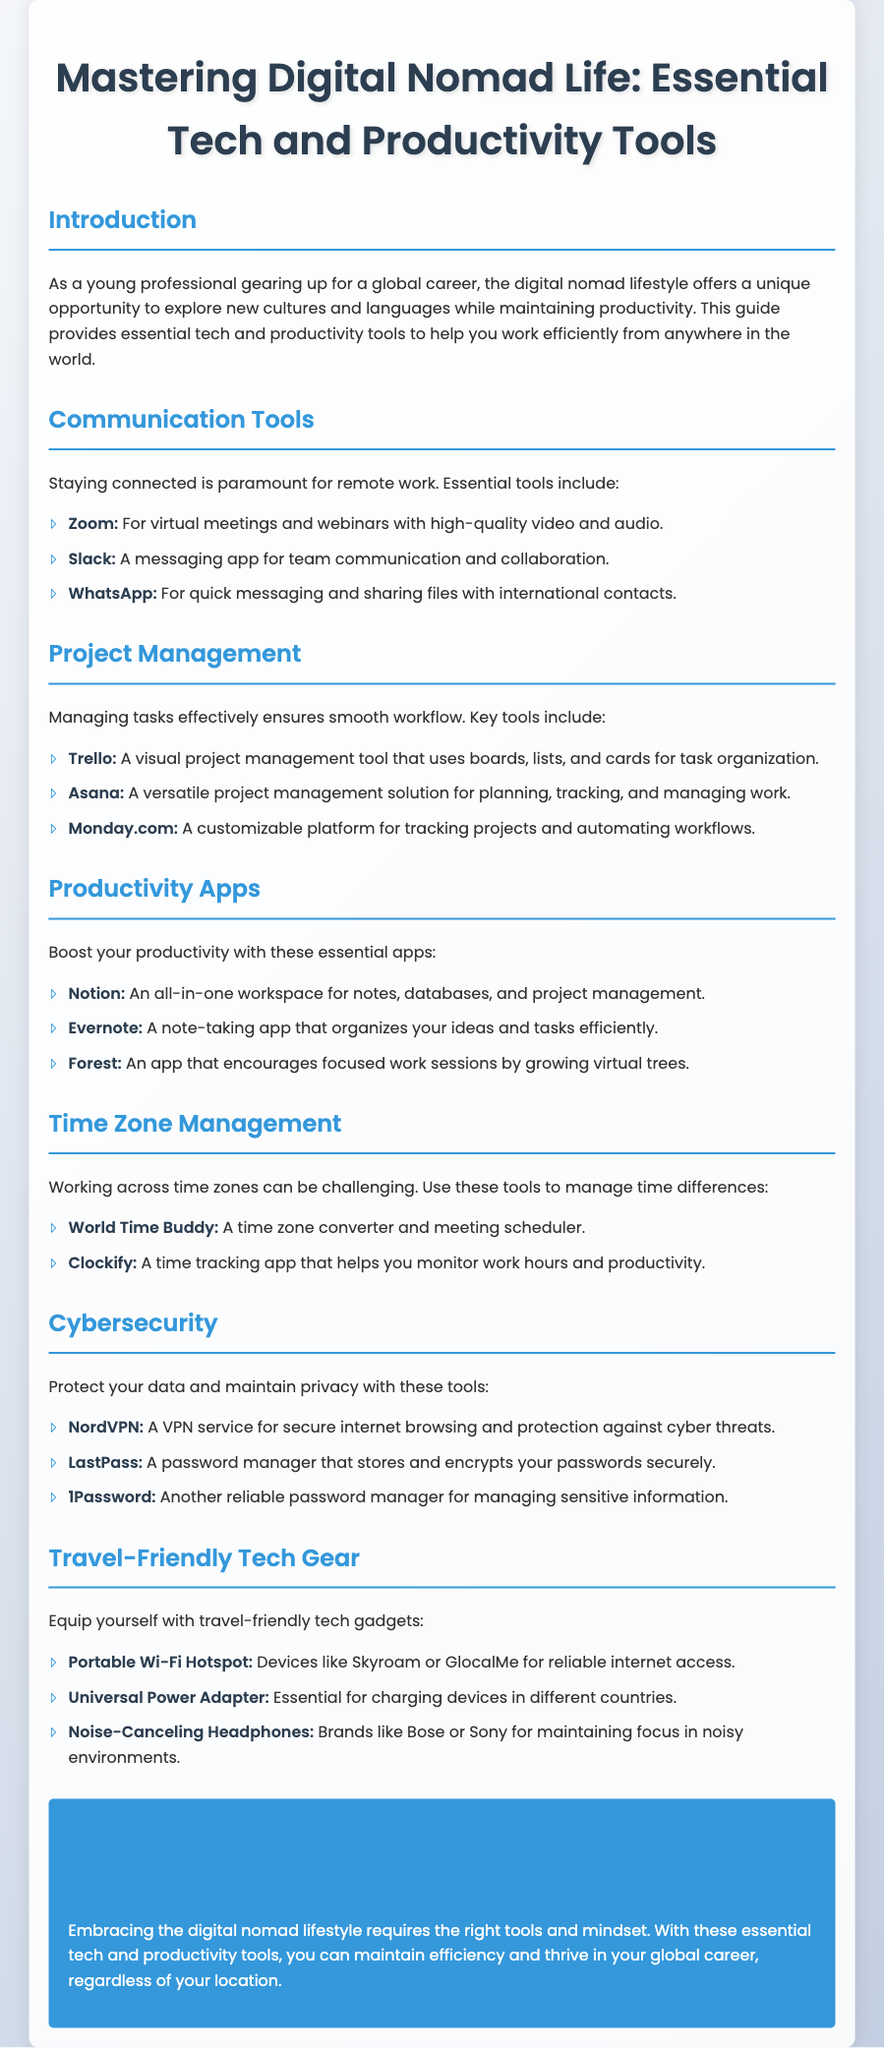what is the title of the guide? The main title of the document is presented in a prominent header at the beginning.
Answer: Mastering Digital Nomad Life: Essential Tech and Productivity Tools what is one example of a communication tool? The document lists several tools under the communication category, and each example reflects a specific tool used for communication.
Answer: Zoom how many project management tools are mentioned? The document explicitly outlines the tools in the project management section which provides a total count.
Answer: 3 which app encourages focused work sessions by growing virtual trees? The document states specific functions of the productivity apps, including features associated with one particular app.
Answer: Forest what tool is used for secure internet browsing? The cybersecurity section of the document includes tools that specifically focus on internet security, naming one of the featured tools.
Answer: NordVPN which portable device is recommended for reliable internet access? The travel-friendly tech gear section highlights specific devices that facilitate internet connectivity while traveling.
Answer: Portable Wi-Fi Hotspot what type of adapter is essential for charging devices in different countries? The document provides information on necessary travel tech accessories, focusing on a specific type of adapter.
Answer: Universal Power Adapter name one password manager mentioned in the guide. The cybersecurity section identifies several password management tools available for securing sensitive information.
Answer: LastPass 